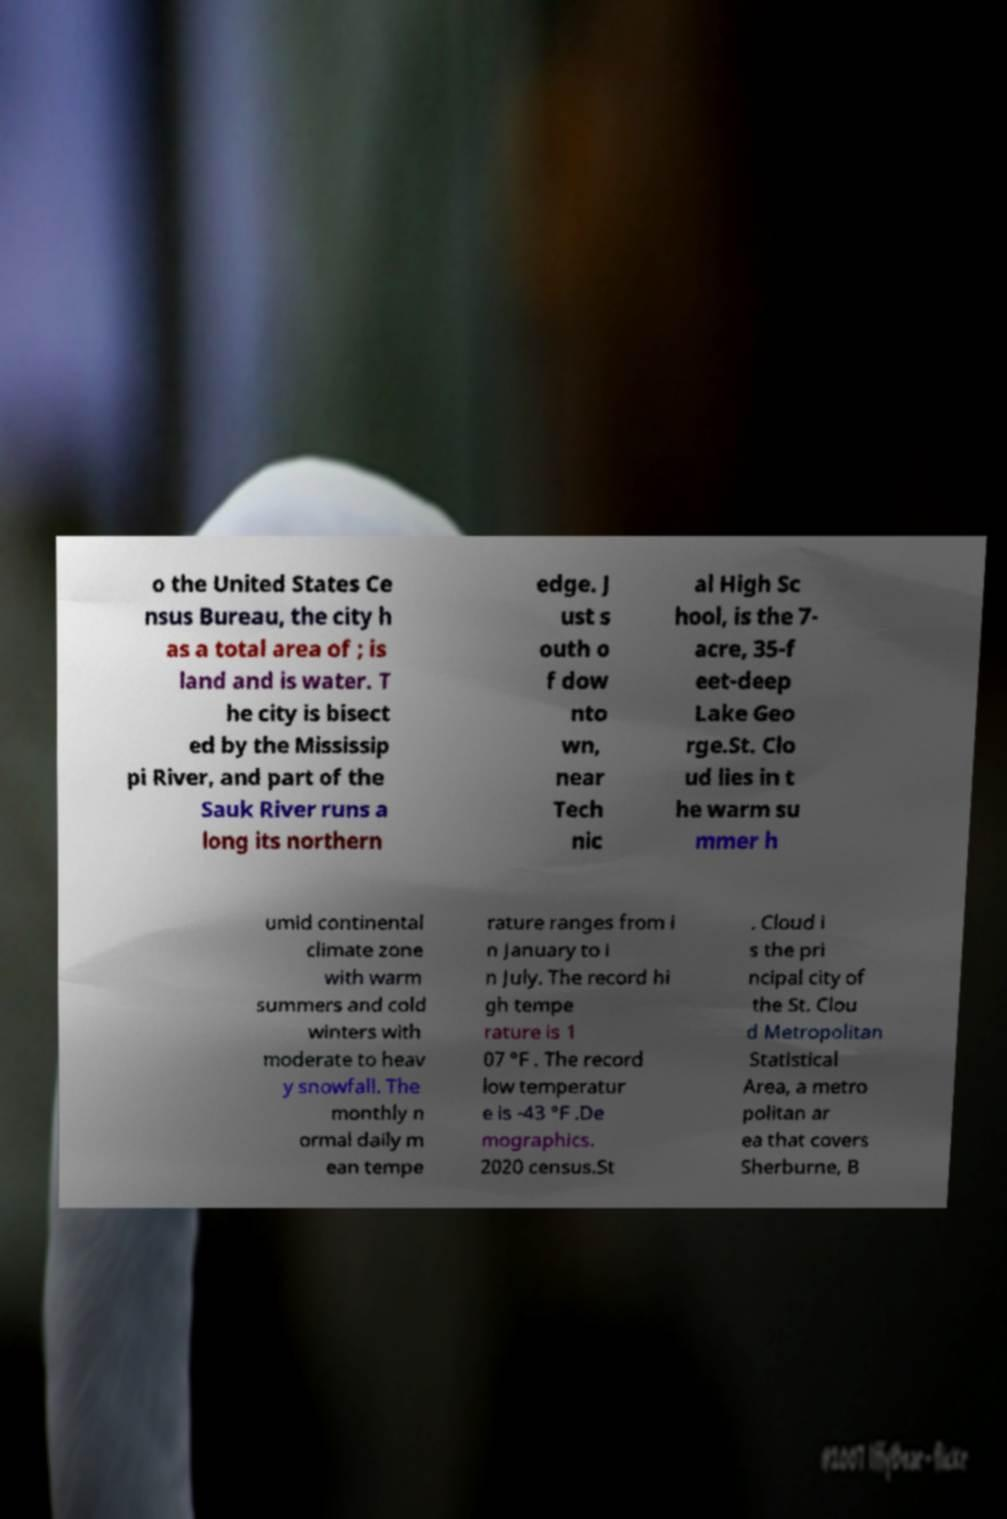Please read and relay the text visible in this image. What does it say? o the United States Ce nsus Bureau, the city h as a total area of ; is land and is water. T he city is bisect ed by the Mississip pi River, and part of the Sauk River runs a long its northern edge. J ust s outh o f dow nto wn, near Tech nic al High Sc hool, is the 7- acre, 35-f eet-deep Lake Geo rge.St. Clo ud lies in t he warm su mmer h umid continental climate zone with warm summers and cold winters with moderate to heav y snowfall. The monthly n ormal daily m ean tempe rature ranges from i n January to i n July. The record hi gh tempe rature is 1 07 °F . The record low temperatur e is -43 °F .De mographics. 2020 census.St . Cloud i s the pri ncipal city of the St. Clou d Metropolitan Statistical Area, a metro politan ar ea that covers Sherburne, B 